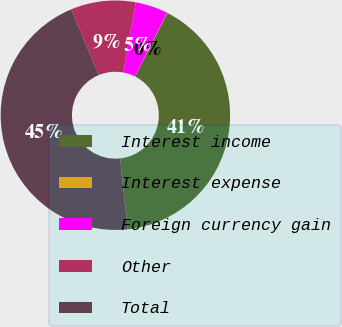Convert chart. <chart><loc_0><loc_0><loc_500><loc_500><pie_chart><fcel>Interest income<fcel>Interest expense<fcel>Foreign currency gain<fcel>Other<fcel>Total<nl><fcel>40.79%<fcel>0.05%<fcel>4.59%<fcel>9.13%<fcel>45.45%<nl></chart> 